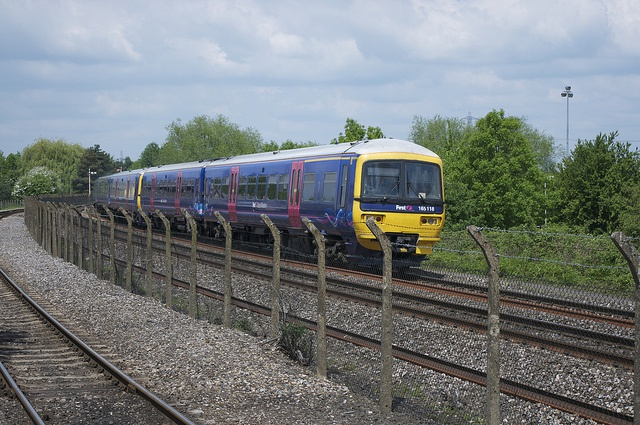Describe the objects in this image and their specific colors. I can see a train in darkgray, gray, black, and navy tones in this image. 